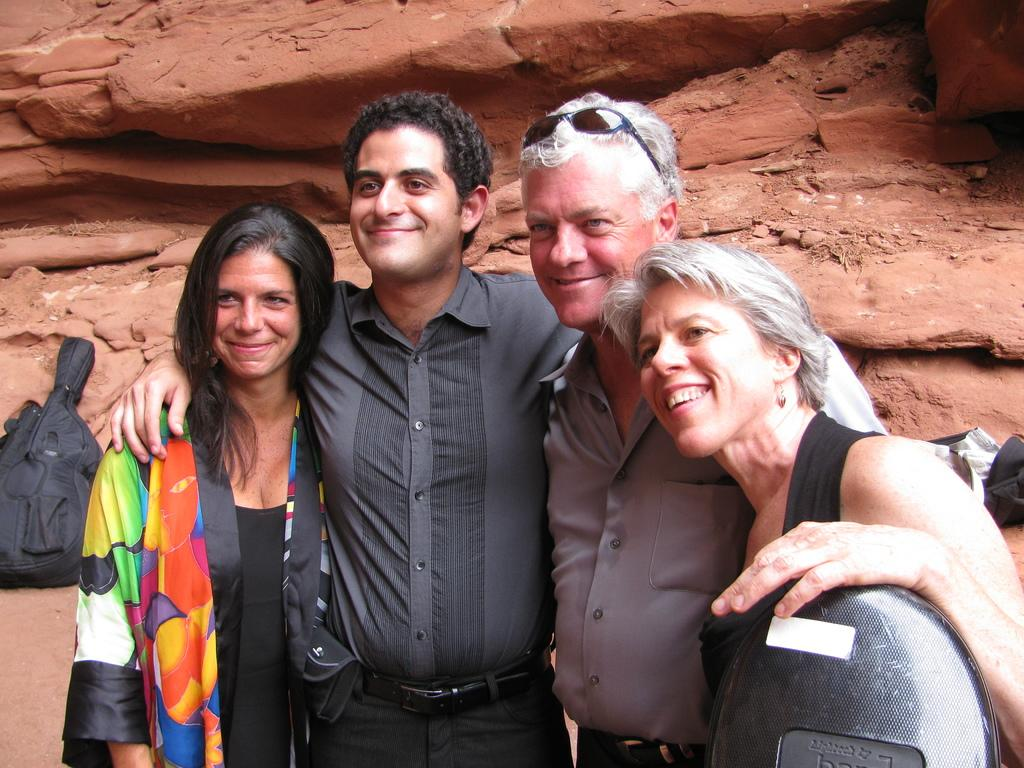What are the people in the image doing? The persons standing in the image are smiling. What can be seen on the ground in the image? There are bags on the ground in the image. What is visible in the background of the image? There are rocks visible in the background of the image. What type of oatmeal is being served to the rat in the image? There is no rat or oatmeal present in the image. Can you tell me the name of the judge in the image? There is no judge present in the image. 